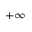<formula> <loc_0><loc_0><loc_500><loc_500>+ \infty</formula> 